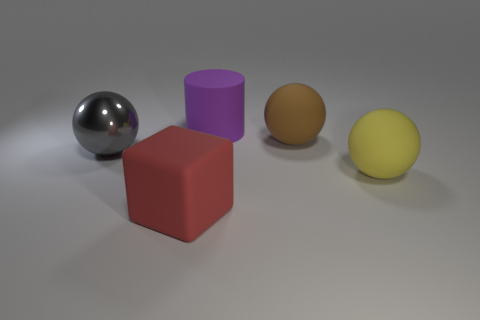What color is the other big metal thing that is the same shape as the big brown object?
Ensure brevity in your answer.  Gray. Is there a purple metal cylinder?
Offer a very short reply. No. Does the thing that is in front of the yellow thing have the same material as the ball that is behind the large gray thing?
Offer a terse response. Yes. What number of objects are either rubber objects that are right of the large red thing or big objects to the left of the rubber block?
Give a very brief answer. 4. What is the shape of the object that is both right of the large purple thing and in front of the brown sphere?
Your answer should be compact. Sphere. What color is the rubber sphere that is the same size as the brown rubber object?
Keep it short and to the point. Yellow. There is a object that is both behind the big yellow ball and left of the cylinder; what material is it made of?
Ensure brevity in your answer.  Metal. What material is the large sphere that is to the left of the purple rubber cylinder?
Give a very brief answer. Metal. Do the gray thing and the purple rubber thing have the same shape?
Offer a very short reply. No. What number of other things are there of the same shape as the red matte object?
Your answer should be compact. 0. 